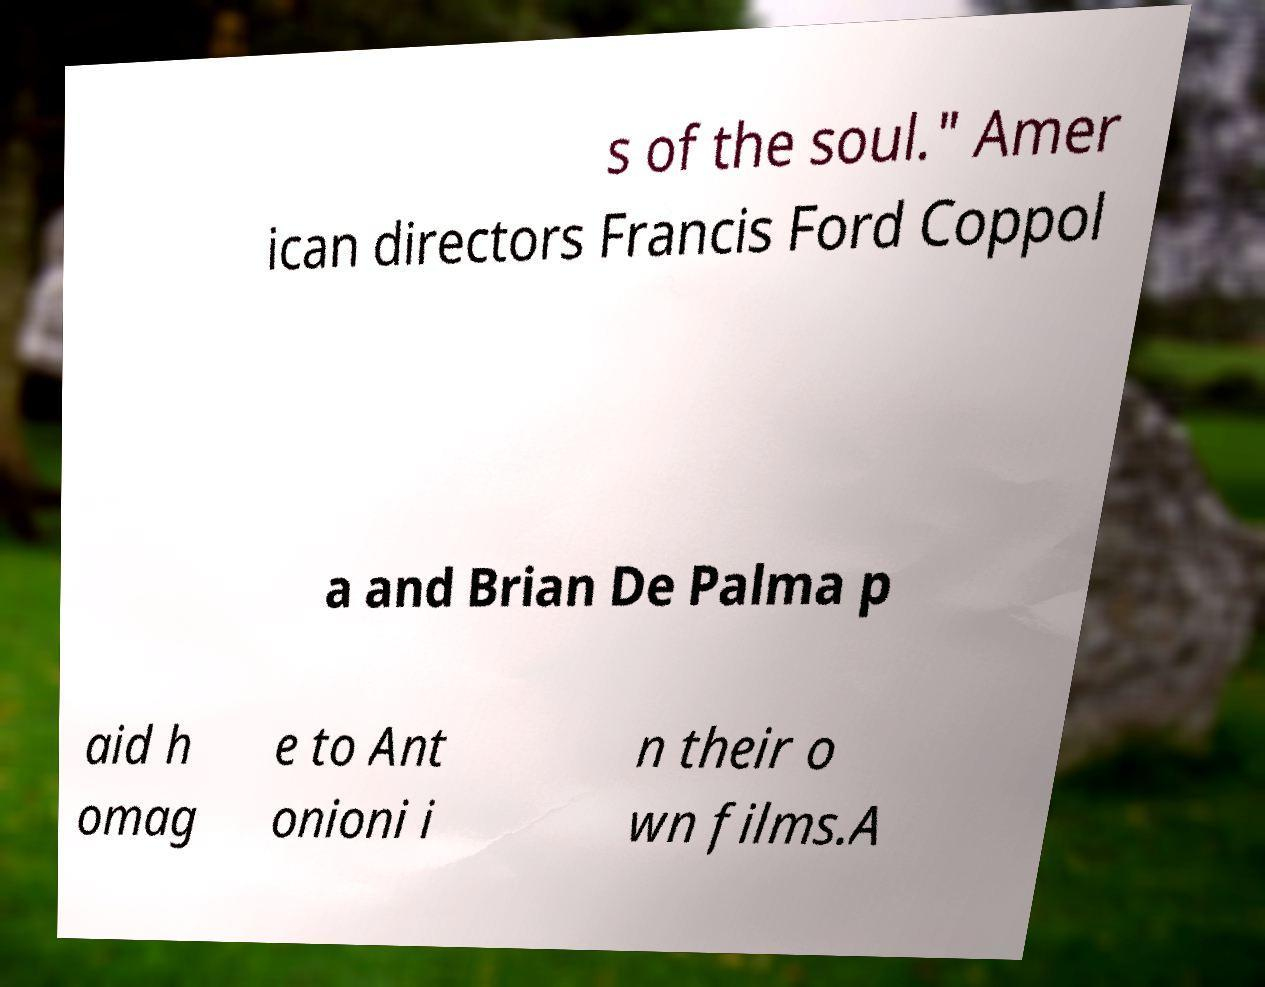For documentation purposes, I need the text within this image transcribed. Could you provide that? s of the soul." Amer ican directors Francis Ford Coppol a and Brian De Palma p aid h omag e to Ant onioni i n their o wn films.A 